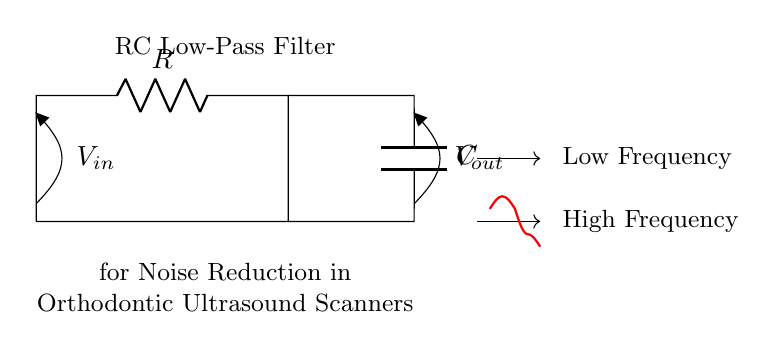what type of circuit is shown? The circuit diagram illustrates a resistor-capacitor combination used as a low-pass filter, indicated by the presence of a resistor and capacitor connected in a specific configuration.
Answer: RC low-pass filter what is the function of the resistor in this circuit? The resistor restricts current flow and, in combination with the capacitor, helps determine the cut-off frequency of the low-pass filter, allowing low-frequency signals to pass while attenuating high-frequency noise.
Answer: Current restriction what does 'V in' represent? 'V in' refers to the input voltage applied to the circuit, which is the voltage signal entering the filter from an external source.
Answer: Input voltage what is the purpose of using this RC low-pass filter? The purpose of this filter is to reduce high-frequency noise in orthodontic ultrasound scanners, effectively smoothing out the input signal for better clarity in readings.
Answer: Noise reduction how do you determine the cut-off frequency? The cut-off frequency can be determined using the formula f_c = 1 / (2πRC), where R is the resistance and C is the capacitance values in the circuit. By knowing these values, you can calculate the frequency at which the output starts to decrease significantly.
Answer: 1 / (2πRC) what happens to high-frequency signals in this filter? High-frequency signals are attenuated, meaning their amplitude is reduced significantly as they pass through the filter, allowing only lower frequencies to pass through with minimal change.
Answer: Attenuated what is the role of the capacitor in this circuit? The capacitor in the circuit stores and releases energy, working with the resistor to filter out high-frequency noise and allowing lower-frequency signals to pass through to the output.
Answer: Energy storage 